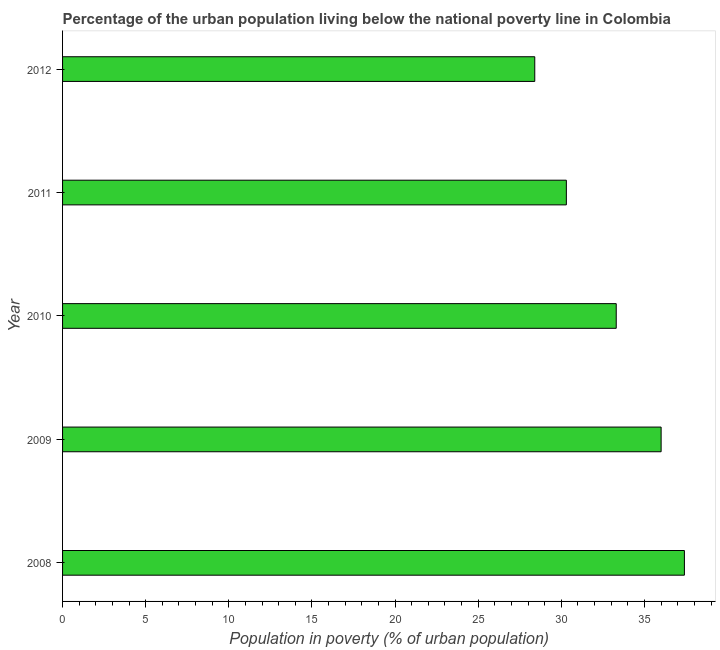Does the graph contain grids?
Make the answer very short. No. What is the title of the graph?
Offer a terse response. Percentage of the urban population living below the national poverty line in Colombia. What is the label or title of the X-axis?
Provide a short and direct response. Population in poverty (% of urban population). What is the percentage of urban population living below poverty line in 2011?
Your answer should be very brief. 30.3. Across all years, what is the maximum percentage of urban population living below poverty line?
Your response must be concise. 37.4. Across all years, what is the minimum percentage of urban population living below poverty line?
Offer a very short reply. 28.4. In which year was the percentage of urban population living below poverty line minimum?
Offer a terse response. 2012. What is the sum of the percentage of urban population living below poverty line?
Make the answer very short. 165.4. What is the difference between the percentage of urban population living below poverty line in 2009 and 2010?
Your response must be concise. 2.7. What is the average percentage of urban population living below poverty line per year?
Offer a very short reply. 33.08. What is the median percentage of urban population living below poverty line?
Your answer should be compact. 33.3. In how many years, is the percentage of urban population living below poverty line greater than 17 %?
Your answer should be compact. 5. What is the ratio of the percentage of urban population living below poverty line in 2008 to that in 2010?
Offer a terse response. 1.12. Is the percentage of urban population living below poverty line in 2008 less than that in 2012?
Give a very brief answer. No. Is the difference between the percentage of urban population living below poverty line in 2008 and 2012 greater than the difference between any two years?
Provide a succinct answer. Yes. In how many years, is the percentage of urban population living below poverty line greater than the average percentage of urban population living below poverty line taken over all years?
Provide a short and direct response. 3. How many bars are there?
Keep it short and to the point. 5. What is the Population in poverty (% of urban population) in 2008?
Provide a succinct answer. 37.4. What is the Population in poverty (% of urban population) in 2009?
Your answer should be compact. 36. What is the Population in poverty (% of urban population) of 2010?
Keep it short and to the point. 33.3. What is the Population in poverty (% of urban population) in 2011?
Your answer should be very brief. 30.3. What is the Population in poverty (% of urban population) of 2012?
Provide a short and direct response. 28.4. What is the difference between the Population in poverty (% of urban population) in 2008 and 2009?
Ensure brevity in your answer.  1.4. What is the difference between the Population in poverty (% of urban population) in 2008 and 2010?
Provide a short and direct response. 4.1. What is the difference between the Population in poverty (% of urban population) in 2009 and 2010?
Provide a short and direct response. 2.7. What is the difference between the Population in poverty (% of urban population) in 2011 and 2012?
Offer a very short reply. 1.9. What is the ratio of the Population in poverty (% of urban population) in 2008 to that in 2009?
Your answer should be compact. 1.04. What is the ratio of the Population in poverty (% of urban population) in 2008 to that in 2010?
Your answer should be very brief. 1.12. What is the ratio of the Population in poverty (% of urban population) in 2008 to that in 2011?
Give a very brief answer. 1.23. What is the ratio of the Population in poverty (% of urban population) in 2008 to that in 2012?
Your answer should be compact. 1.32. What is the ratio of the Population in poverty (% of urban population) in 2009 to that in 2010?
Provide a short and direct response. 1.08. What is the ratio of the Population in poverty (% of urban population) in 2009 to that in 2011?
Your response must be concise. 1.19. What is the ratio of the Population in poverty (% of urban population) in 2009 to that in 2012?
Offer a very short reply. 1.27. What is the ratio of the Population in poverty (% of urban population) in 2010 to that in 2011?
Make the answer very short. 1.1. What is the ratio of the Population in poverty (% of urban population) in 2010 to that in 2012?
Your answer should be compact. 1.17. What is the ratio of the Population in poverty (% of urban population) in 2011 to that in 2012?
Your response must be concise. 1.07. 